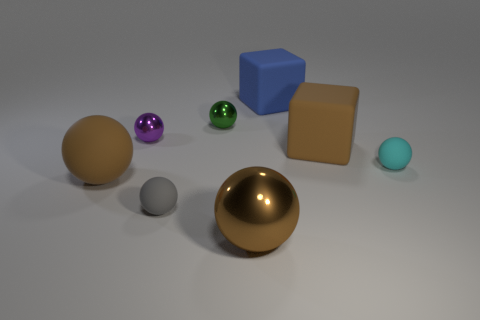How many objects are either cubes behind the small purple metal thing or large rubber cubes in front of the purple ball?
Keep it short and to the point. 2. There is a blue matte thing that is the same size as the brown matte block; what shape is it?
Offer a very short reply. Cube. There is a brown object that is the same material as the purple sphere; what size is it?
Your answer should be compact. Large. Is the purple metal thing the same shape as the large blue matte object?
Your response must be concise. No. The other matte sphere that is the same size as the gray matte ball is what color?
Give a very brief answer. Cyan. What is the size of the brown thing that is the same shape as the blue matte object?
Your response must be concise. Large. What shape is the brown rubber object that is right of the gray rubber sphere?
Your answer should be very brief. Cube. There is a big metallic object; is its shape the same as the small metal thing to the left of the green shiny object?
Offer a very short reply. Yes. Are there the same number of blue rubber cubes that are right of the tiny cyan rubber thing and cubes that are on the right side of the big blue matte thing?
Provide a short and direct response. No. There is a metal object that is the same color as the big rubber sphere; what is its shape?
Your response must be concise. Sphere. 